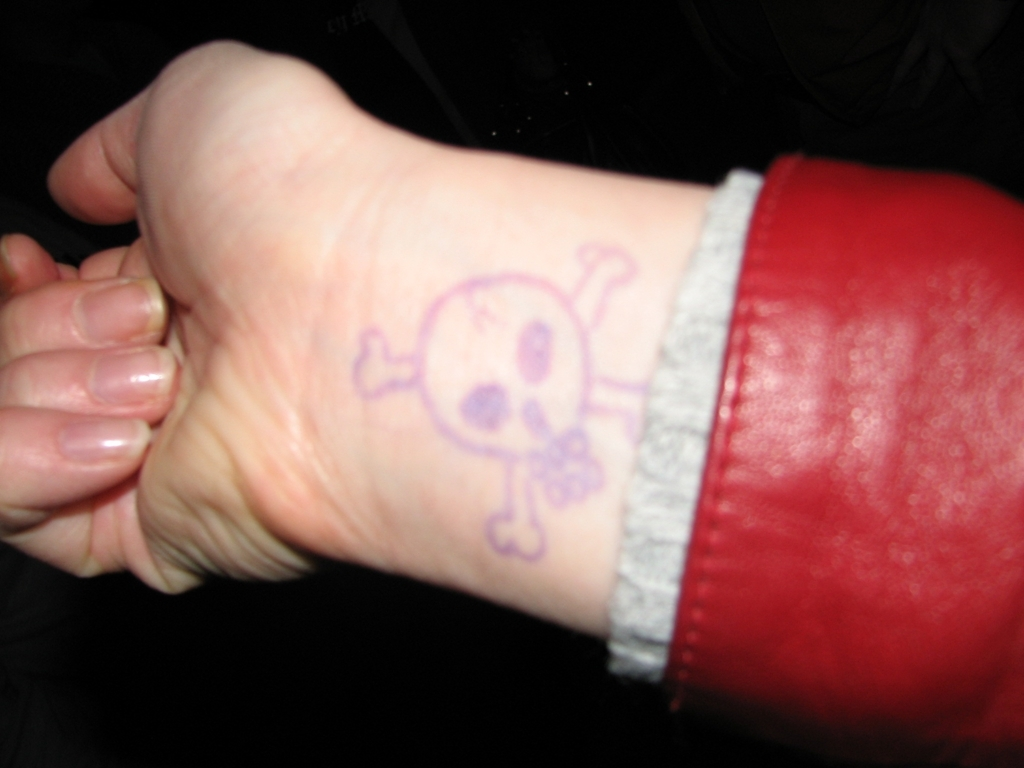Are the fingers in the distance clear? The fingers positioned in the background of the image are slightly obscured, lacking sharpness and fine detail. This limits the viewer's ability to discern specific features clearly, which may be due to the shallow depth of field or motion blur. 